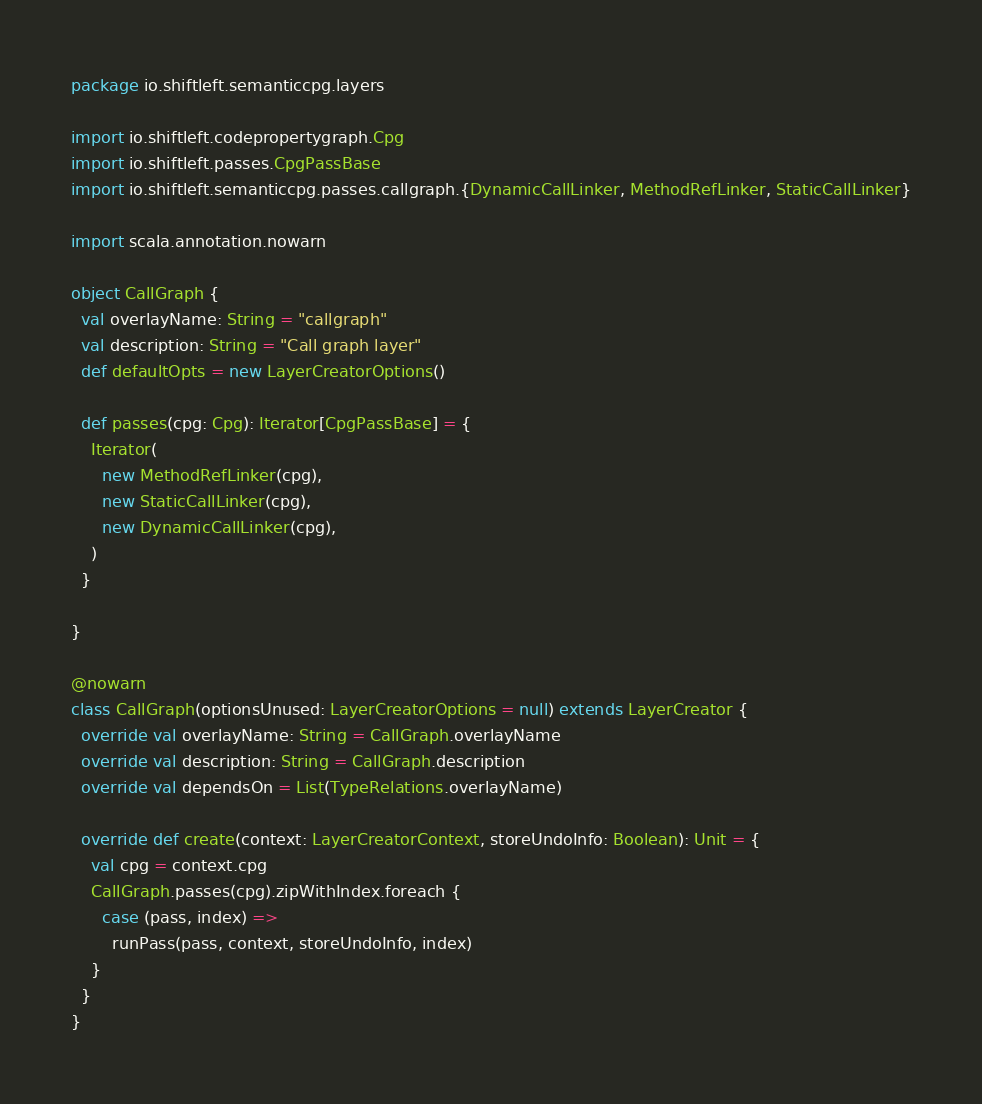<code> <loc_0><loc_0><loc_500><loc_500><_Scala_>package io.shiftleft.semanticcpg.layers

import io.shiftleft.codepropertygraph.Cpg
import io.shiftleft.passes.CpgPassBase
import io.shiftleft.semanticcpg.passes.callgraph.{DynamicCallLinker, MethodRefLinker, StaticCallLinker}

import scala.annotation.nowarn

object CallGraph {
  val overlayName: String = "callgraph"
  val description: String = "Call graph layer"
  def defaultOpts = new LayerCreatorOptions()

  def passes(cpg: Cpg): Iterator[CpgPassBase] = {
    Iterator(
      new MethodRefLinker(cpg),
      new StaticCallLinker(cpg),
      new DynamicCallLinker(cpg),
    )
  }

}

@nowarn
class CallGraph(optionsUnused: LayerCreatorOptions = null) extends LayerCreator {
  override val overlayName: String = CallGraph.overlayName
  override val description: String = CallGraph.description
  override val dependsOn = List(TypeRelations.overlayName)

  override def create(context: LayerCreatorContext, storeUndoInfo: Boolean): Unit = {
    val cpg = context.cpg
    CallGraph.passes(cpg).zipWithIndex.foreach {
      case (pass, index) =>
        runPass(pass, context, storeUndoInfo, index)
    }
  }
}
</code> 